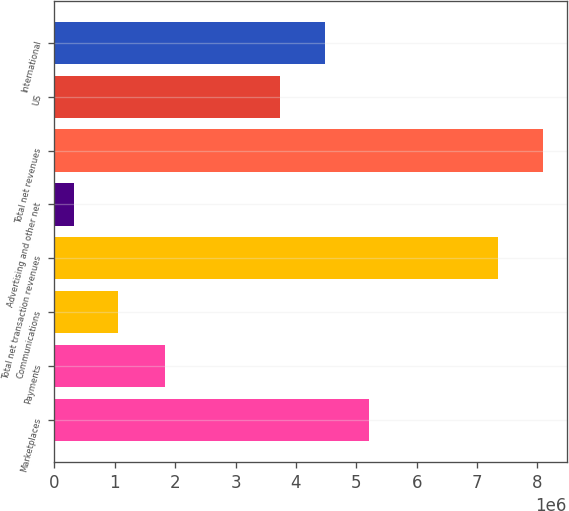Convert chart. <chart><loc_0><loc_0><loc_500><loc_500><bar_chart><fcel>Marketplaces<fcel>Payments<fcel>Communications<fcel>Total net transaction revenues<fcel>Advertising and other net<fcel>Total net revenues<fcel>US<fcel>International<nl><fcel>5.21279e+06<fcel>1.83854e+06<fcel>1.05677e+06<fcel>7.35062e+06<fcel>321712<fcel>8.08568e+06<fcel>3.74267e+06<fcel>4.47773e+06<nl></chart> 